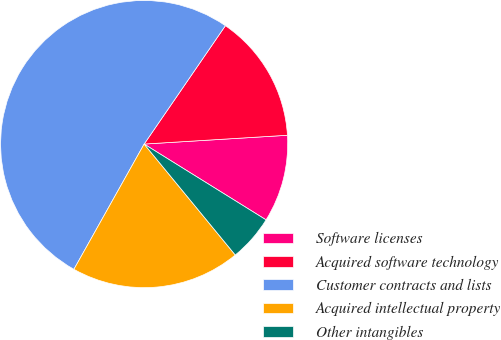Convert chart to OTSL. <chart><loc_0><loc_0><loc_500><loc_500><pie_chart><fcel>Software licenses<fcel>Acquired software technology<fcel>Customer contracts and lists<fcel>Acquired intellectual property<fcel>Other intangibles<nl><fcel>9.83%<fcel>14.45%<fcel>51.44%<fcel>19.08%<fcel>5.2%<nl></chart> 